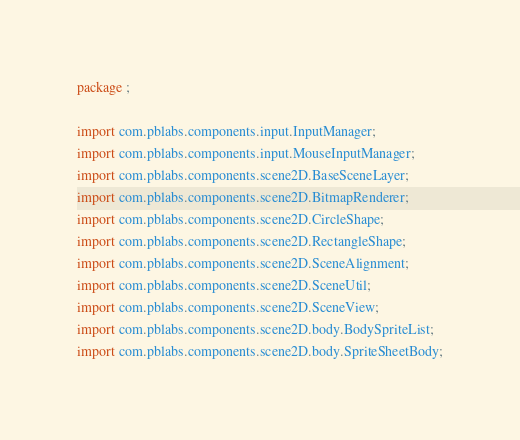<code> <loc_0><loc_0><loc_500><loc_500><_Haxe_>package ;

import com.pblabs.components.input.InputManager;
import com.pblabs.components.input.MouseInputManager;
import com.pblabs.components.scene2D.BaseSceneLayer;
import com.pblabs.components.scene2D.BitmapRenderer;
import com.pblabs.components.scene2D.CircleShape;
import com.pblabs.components.scene2D.RectangleShape;
import com.pblabs.components.scene2D.SceneAlignment;
import com.pblabs.components.scene2D.SceneUtil;
import com.pblabs.components.scene2D.SceneView;
import com.pblabs.components.scene2D.body.BodySpriteList;
import com.pblabs.components.scene2D.body.SpriteSheetBody;</code> 